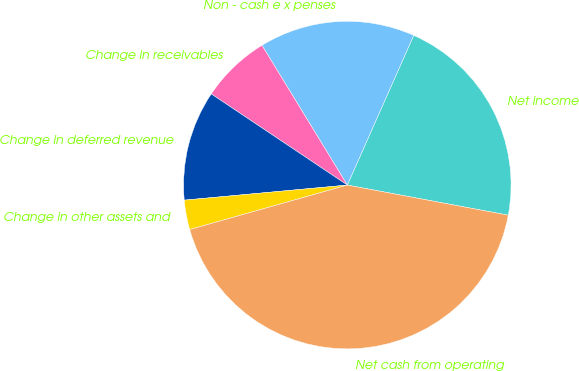<chart> <loc_0><loc_0><loc_500><loc_500><pie_chart><fcel>Net income<fcel>Non - cash e x penses<fcel>Change in receivables<fcel>Change in deferred revenue<fcel>Change in other assets and<fcel>Net cash from operating<nl><fcel>21.3%<fcel>15.37%<fcel>6.88%<fcel>10.86%<fcel>2.91%<fcel>42.68%<nl></chart> 